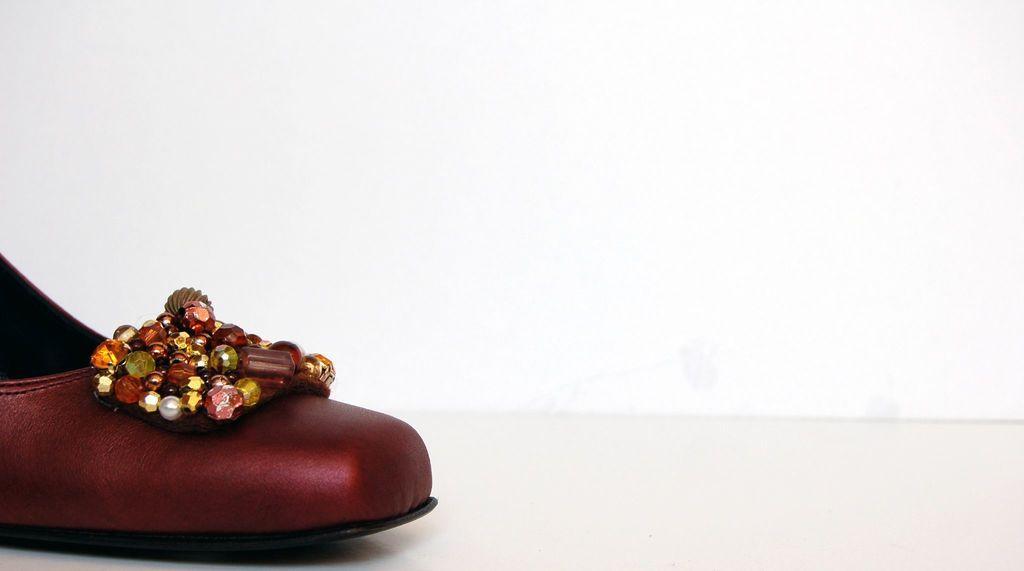Describe this image in one or two sentences. In this picture we can see footwear on white surface. In the background of the image it is white. 